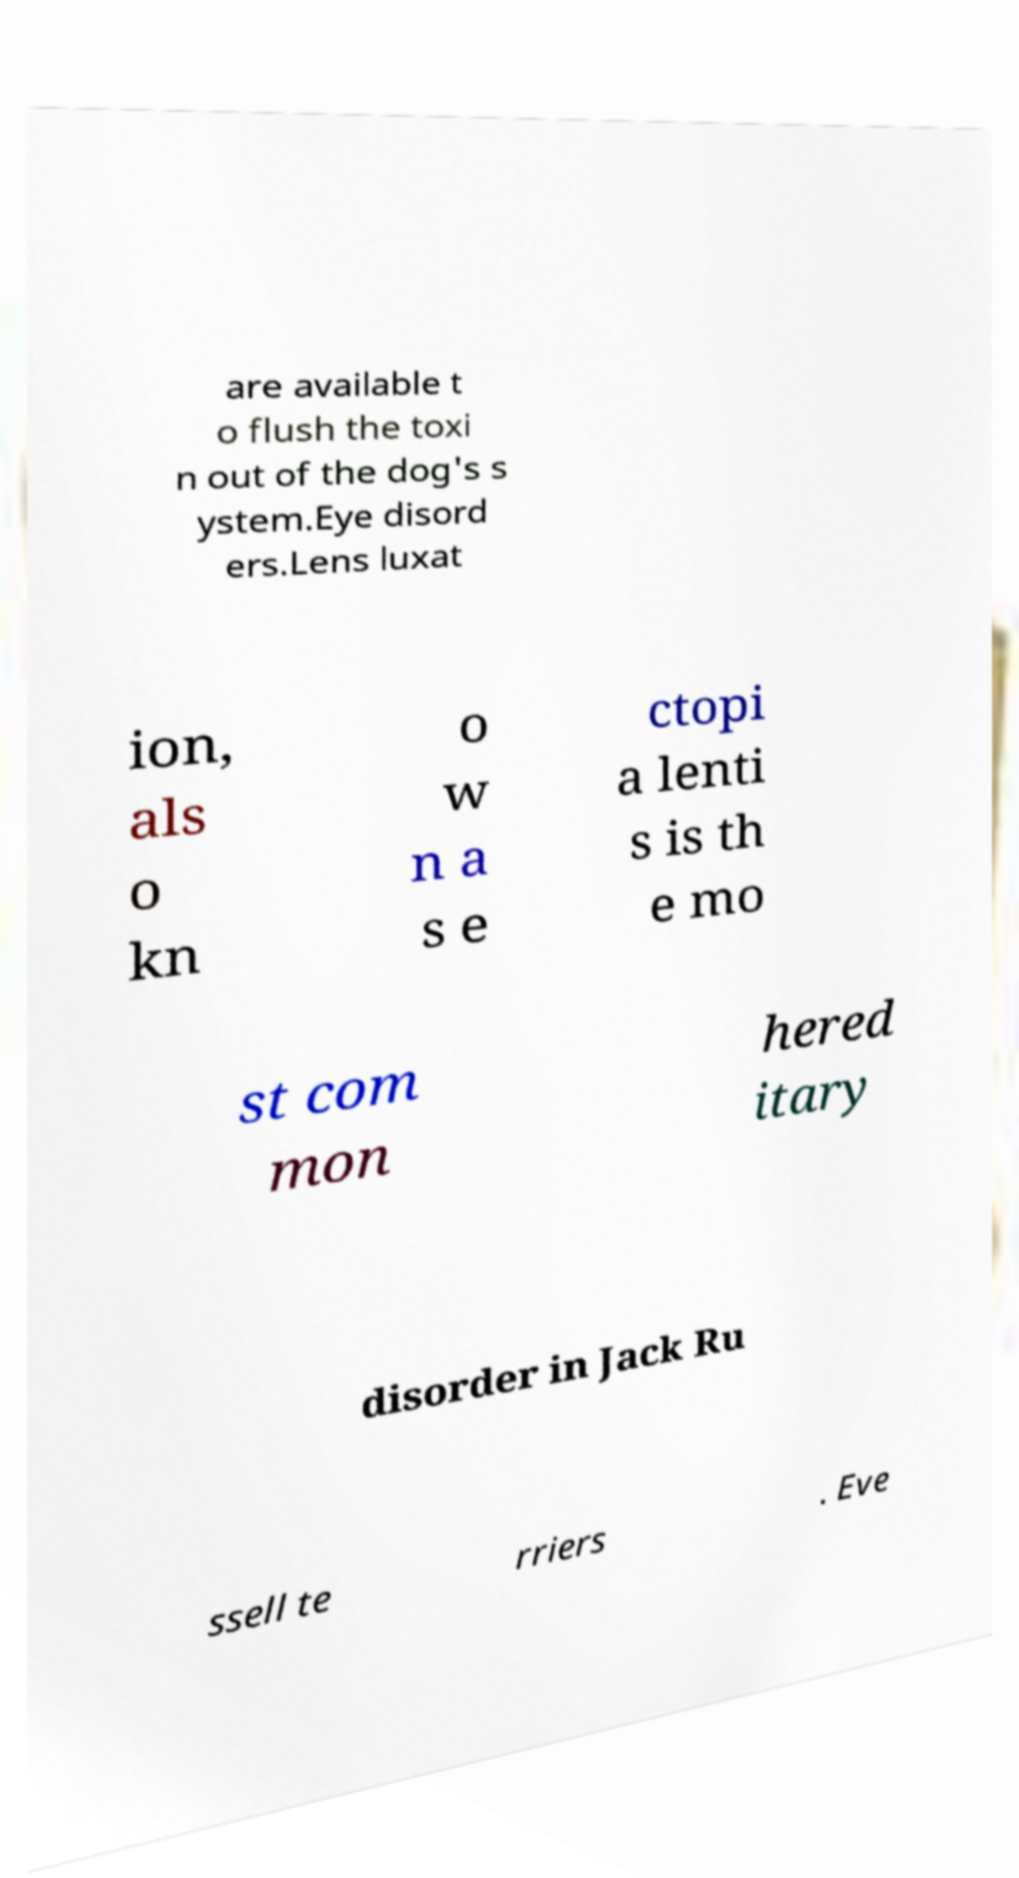Can you accurately transcribe the text from the provided image for me? are available t o flush the toxi n out of the dog's s ystem.Eye disord ers.Lens luxat ion, als o kn o w n a s e ctopi a lenti s is th e mo st com mon hered itary disorder in Jack Ru ssell te rriers . Eve 